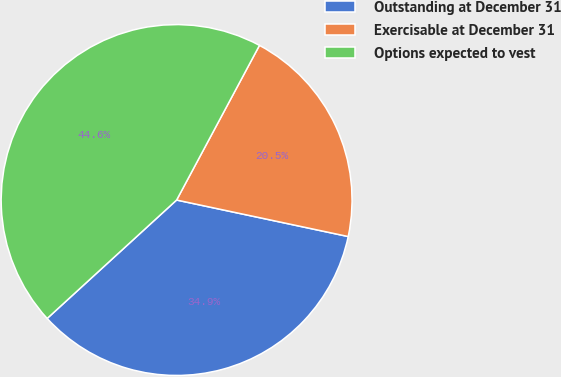<chart> <loc_0><loc_0><loc_500><loc_500><pie_chart><fcel>Outstanding at December 31<fcel>Exercisable at December 31<fcel>Options expected to vest<nl><fcel>34.87%<fcel>20.51%<fcel>44.62%<nl></chart> 